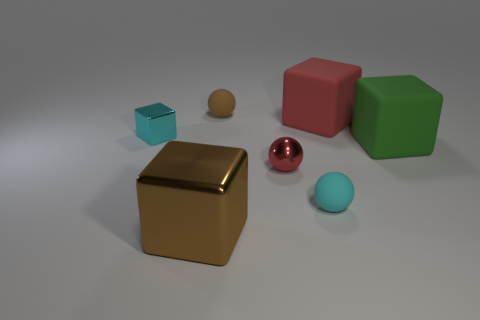Are there the same number of cubes that are behind the small shiny ball and matte balls?
Ensure brevity in your answer.  No. How many big objects have the same material as the tiny cyan sphere?
Your answer should be compact. 2. The other ball that is the same material as the tiny cyan sphere is what color?
Keep it short and to the point. Brown. Is the tiny cyan rubber object the same shape as the tiny red thing?
Keep it short and to the point. Yes. There is a cyan object left of the small cyan thing on the right side of the big brown metallic thing; is there a tiny thing that is on the right side of it?
Ensure brevity in your answer.  Yes. What number of other metallic cubes have the same color as the small metallic block?
Your answer should be compact. 0. What is the shape of the red thing that is the same size as the brown metal block?
Provide a succinct answer. Cube. Are there any cyan matte objects left of the red metal thing?
Offer a terse response. No. Do the brown metal thing and the metallic sphere have the same size?
Offer a very short reply. No. What shape is the cyan object that is behind the green cube?
Make the answer very short. Cube. 